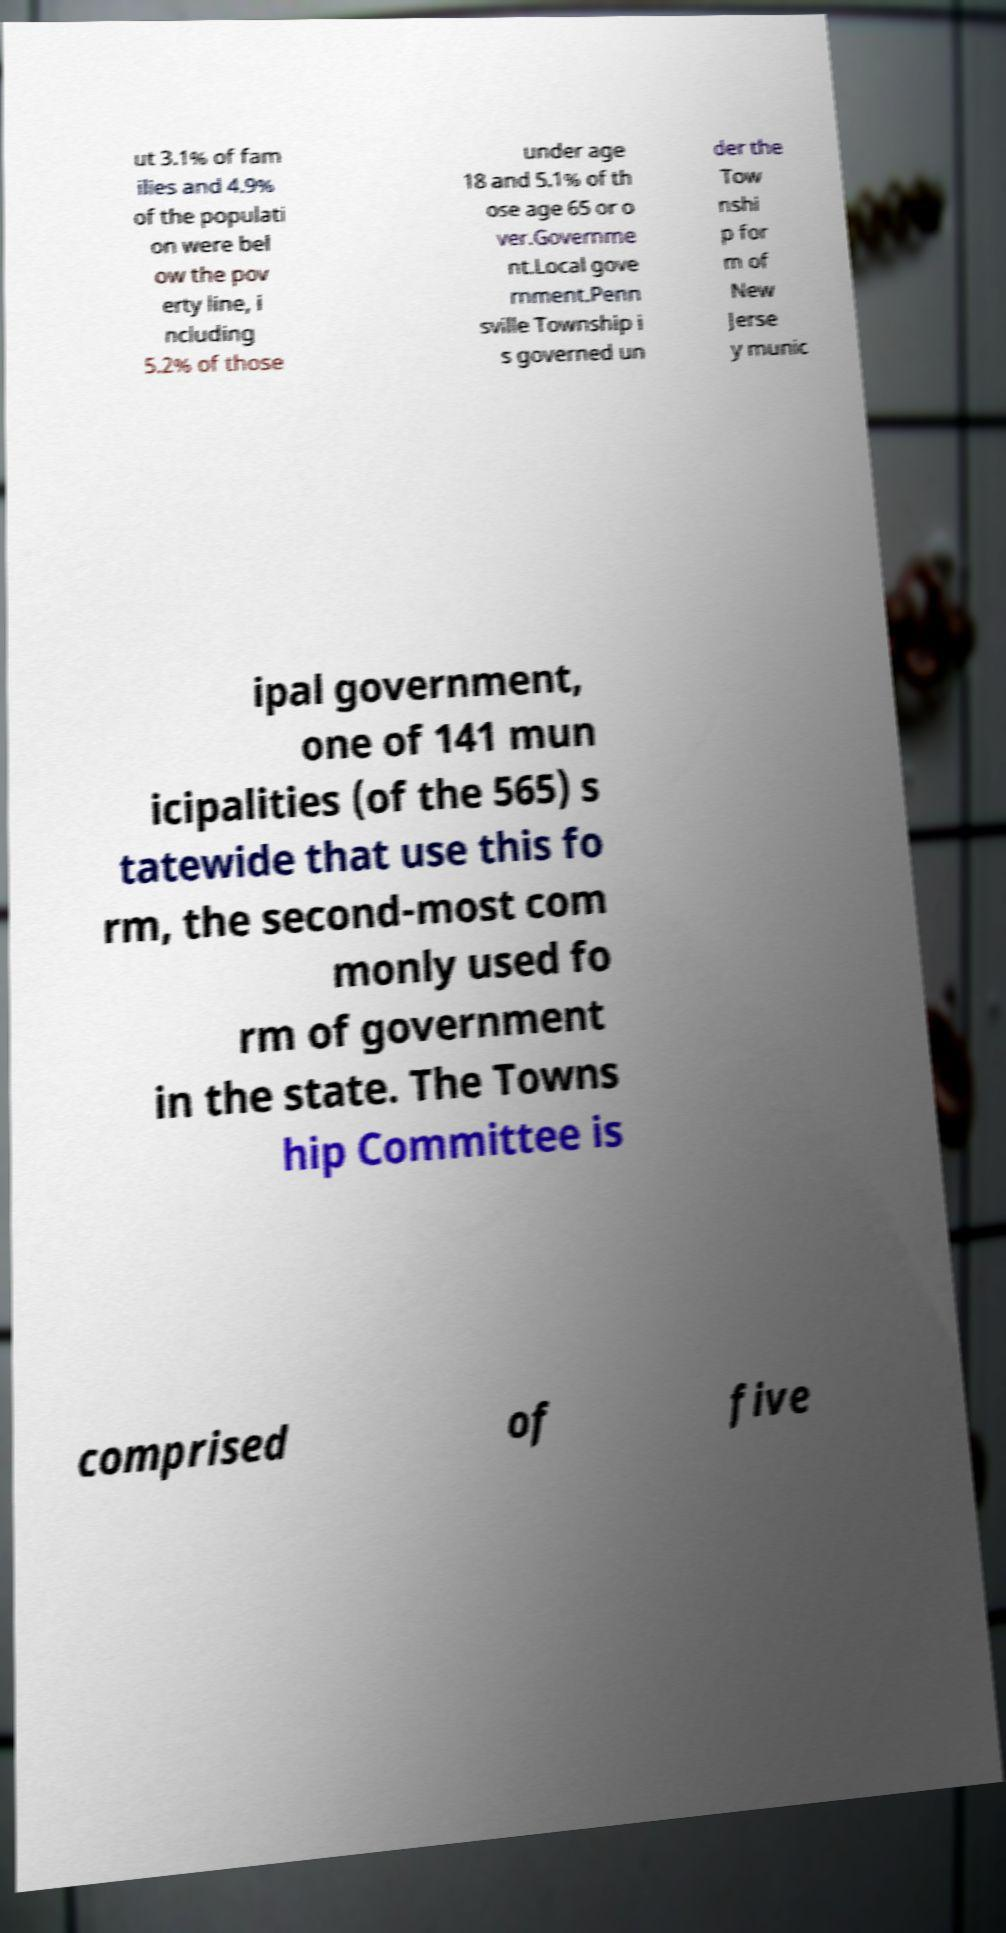I need the written content from this picture converted into text. Can you do that? ut 3.1% of fam ilies and 4.9% of the populati on were bel ow the pov erty line, i ncluding 5.2% of those under age 18 and 5.1% of th ose age 65 or o ver.Governme nt.Local gove rnment.Penn sville Township i s governed un der the Tow nshi p for m of New Jerse y munic ipal government, one of 141 mun icipalities (of the 565) s tatewide that use this fo rm, the second-most com monly used fo rm of government in the state. The Towns hip Committee is comprised of five 